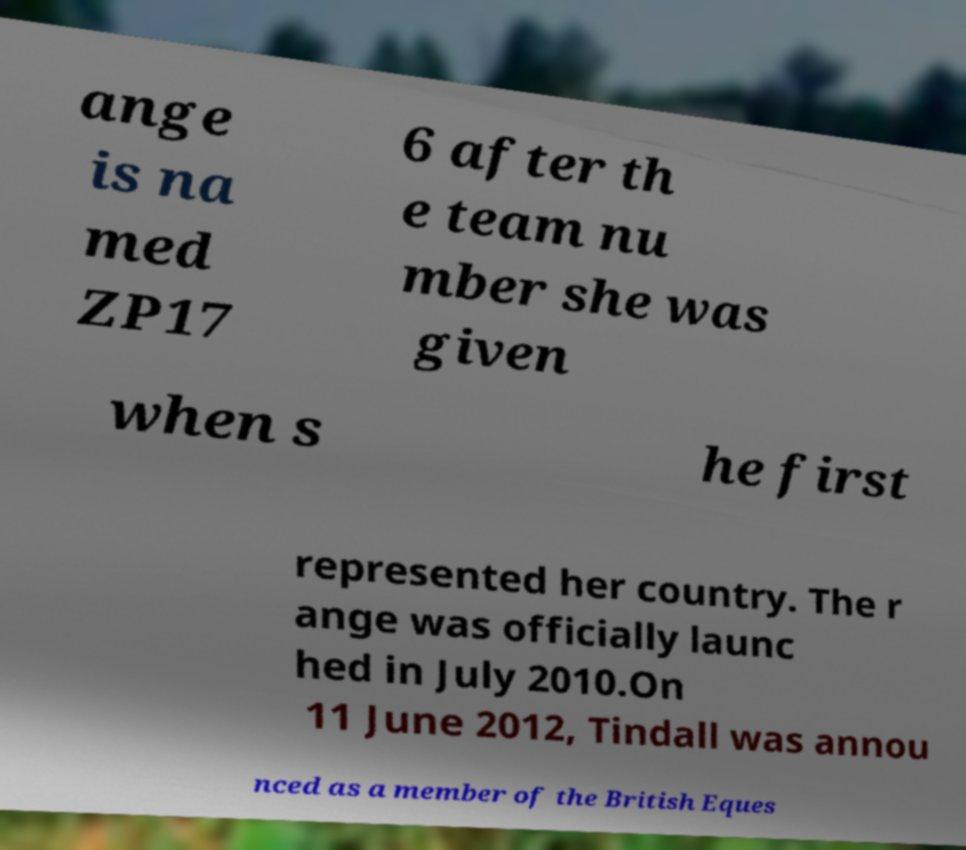Could you assist in decoding the text presented in this image and type it out clearly? ange is na med ZP17 6 after th e team nu mber she was given when s he first represented her country. The r ange was officially launc hed in July 2010.On 11 June 2012, Tindall was annou nced as a member of the British Eques 